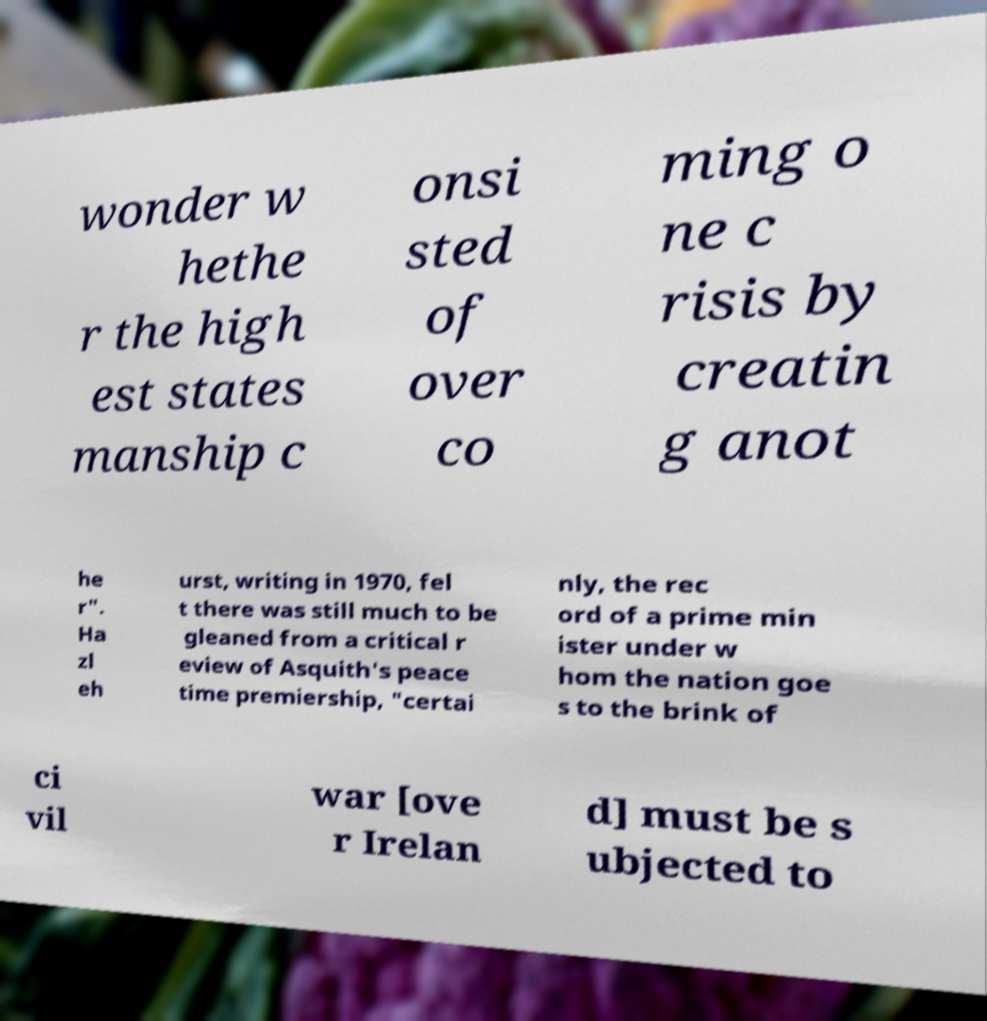There's text embedded in this image that I need extracted. Can you transcribe it verbatim? wonder w hethe r the high est states manship c onsi sted of over co ming o ne c risis by creatin g anot he r". Ha zl eh urst, writing in 1970, fel t there was still much to be gleaned from a critical r eview of Asquith's peace time premiership, "certai nly, the rec ord of a prime min ister under w hom the nation goe s to the brink of ci vil war [ove r Irelan d] must be s ubjected to 